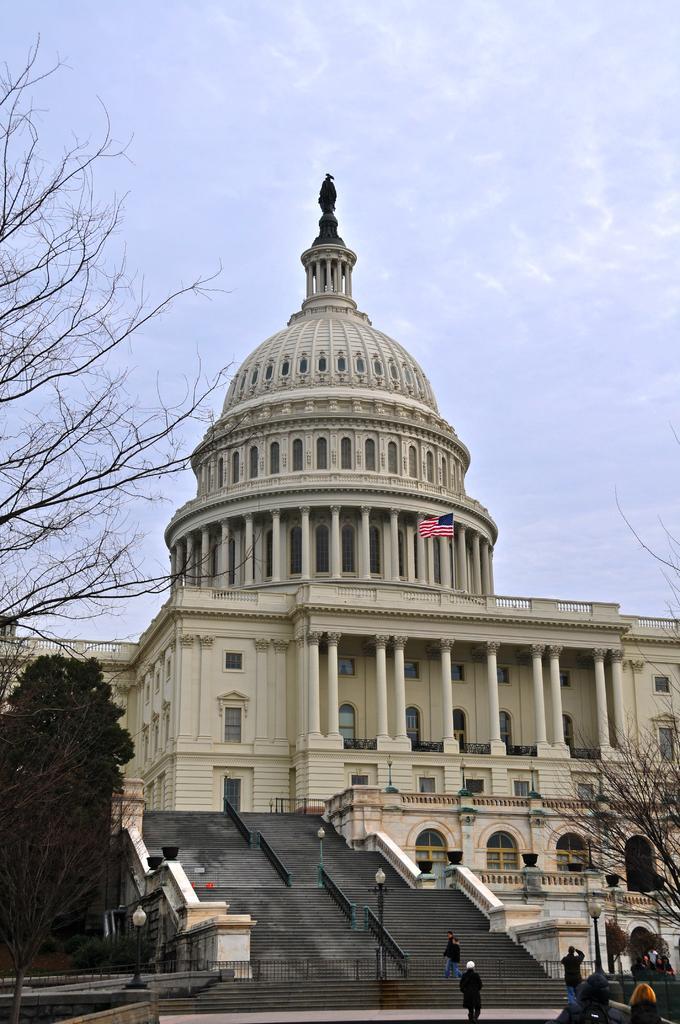In one or two sentences, can you explain what this image depicts? In this image there is a building. There is a flag on the building. There are steps to the building. Beside the steps there are railings and light poles. There are few people walking in the image. There are trees and light poles. At the top there is the sky. 